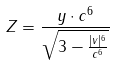Convert formula to latex. <formula><loc_0><loc_0><loc_500><loc_500>Z = \frac { y \cdot c ^ { 6 } } { \sqrt { 3 - \frac { | v | ^ { 6 } } { c ^ { 6 } } } }</formula> 